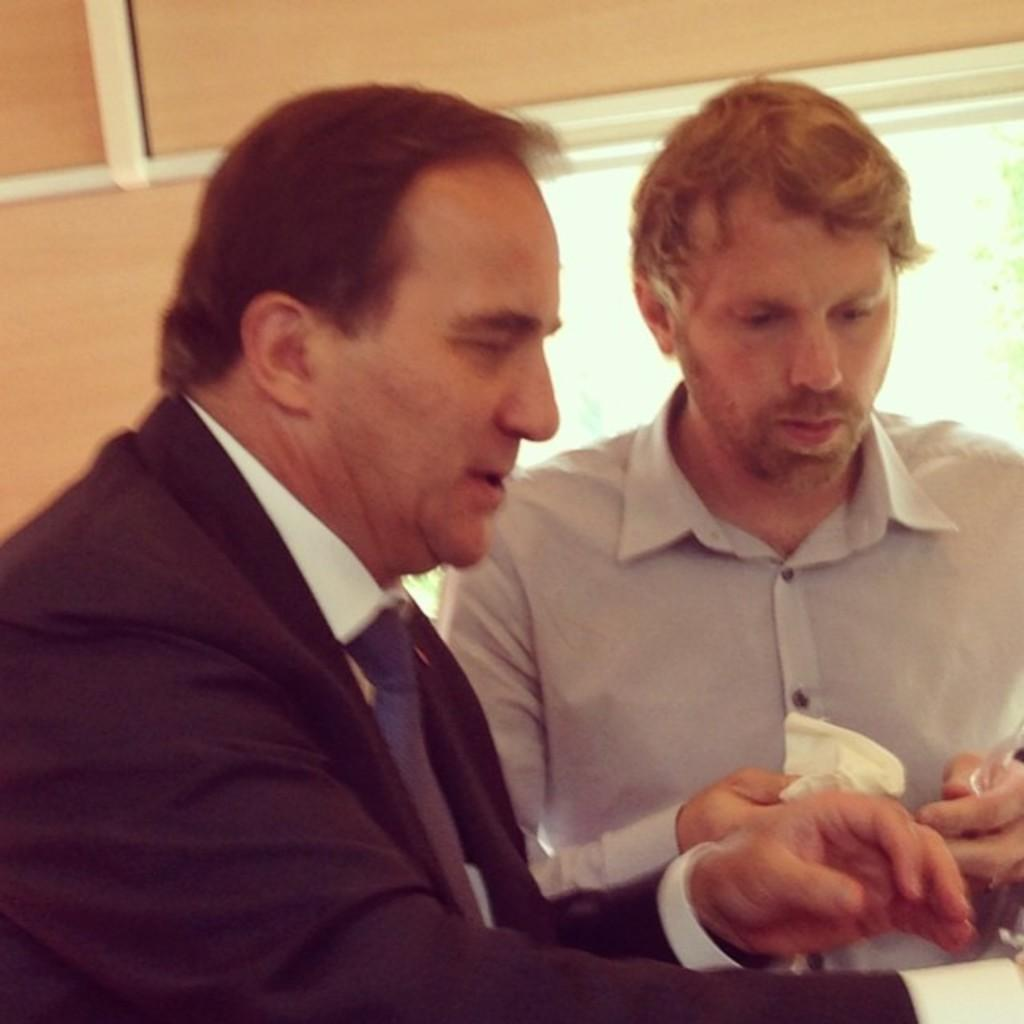How many people are in the image? There are two men in the image. What are the men doing in the image? The men are looking at something. What can be seen in the background of the image? There is a window in the background of the image. What type of grape is being used for the selection process in the image? There is no grape or selection process present in the image. Where is the mailbox located in the image? There is no mailbox present in the image. 